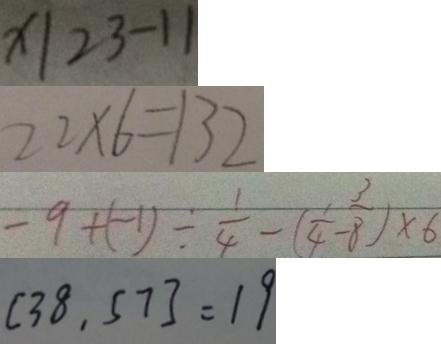<formula> <loc_0><loc_0><loc_500><loc_500>x \vert 2 3 - 1 1 
 2 2 \times 6 = 1 3 2 
 - 9 + ( - 1 ) \div \frac { 1 } { 4 } - ( \frac { 1 } { 4 } - \frac { 3 } { 8 } ) \times 6 
 [ 3 8 , 5 7 ] = 1 9</formula> 